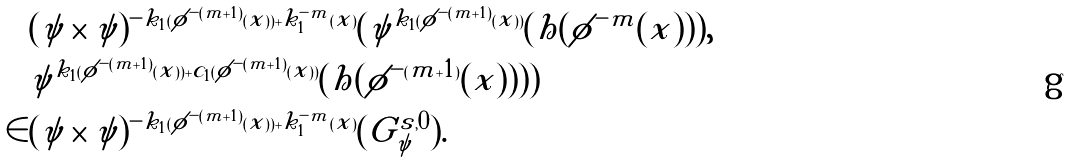Convert formula to latex. <formula><loc_0><loc_0><loc_500><loc_500>& ( \psi \times \psi ) ^ { - k _ { 1 } ( \phi ^ { - ( m + 1 ) } ( x ) ) + k _ { 1 } ^ { - m } ( x ) } ( \psi ^ { k _ { 1 } ( \phi ^ { - ( m + 1 ) } ( x ) ) } ( h ( \phi ^ { - m } ( x ) ) ) , \\ & \psi ^ { k _ { 1 } ( \phi ^ { - ( m + 1 ) } ( x ) ) + c _ { 1 } ( \phi ^ { - ( m + 1 ) } ( x ) ) } ( h ( \phi ^ { - ( m + 1 ) } ( x ) ) ) ) \\ \in & ( \psi \times \psi ) ^ { - k _ { 1 } ( \phi ^ { - ( m + 1 ) } ( x ) ) + k _ { 1 } ^ { - m } ( x ) } ( G _ { \psi } ^ { s , 0 } ) .</formula> 